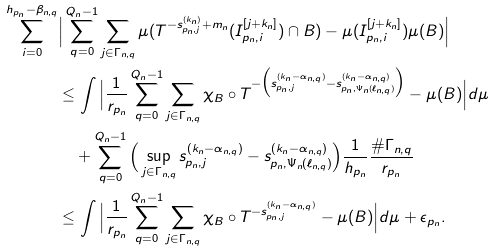Convert formula to latex. <formula><loc_0><loc_0><loc_500><loc_500>\sum _ { i = 0 } ^ { h _ { p _ { n } } - \beta _ { n , q } } & \Big { | } \sum _ { q = 0 } ^ { Q _ { n } - 1 } \sum _ { j \in \Gamma _ { n , q } } \mu ( T ^ { - s _ { p _ { n } , j } ^ { ( k _ { n } ) } + m _ { n } } ( I _ { p _ { n } , i } ^ { [ j + k _ { n } ] } ) \cap B ) - \mu ( I _ { p _ { n } , i } ^ { [ j + k _ { n } ] } ) \mu ( B ) \Big { | } \\ & \leq \int \Big { | } \frac { 1 } { r _ { p _ { n } } } \sum _ { q = 0 } ^ { Q _ { n } - 1 } \sum _ { j \in \Gamma _ { n , q } } \chi _ { B } \circ T ^ { - \Big { ( } s _ { p _ { n } , j } ^ { ( k _ { n } - \alpha _ { n , q } ) } - s _ { p _ { n } , \Psi _ { n } ( \ell _ { n , q } ) } ^ { ( k _ { n } - \alpha _ { n , q } ) } \Big { ) } } - \mu ( B ) \Big { | } d \mu \\ & \quad + \sum _ { q = 0 } ^ { Q _ { n } - 1 } \Big { ( } \sup _ { j \in \Gamma _ { n , q } } s _ { p _ { n } , j } ^ { ( k _ { n } - \alpha _ { n , q } ) } - s _ { p _ { n } , \Psi _ { n } ( \ell _ { n , q } ) } ^ { ( k _ { n } - \alpha _ { n , q } ) } \Big { ) } \frac { 1 } { h _ { p _ { n } } } \frac { \# \Gamma _ { n , q } } { r _ { p _ { n } } } \\ & \leq \int \Big { | } \frac { 1 } { r _ { p _ { n } } } \sum _ { q = 0 } ^ { Q _ { n } - 1 } \sum _ { j \in \Gamma _ { n , q } } \chi _ { B } \circ T ^ { - s _ { p _ { n } , j } ^ { ( k _ { n } - \alpha _ { n , q } ) } } - \mu ( B ) \Big { | } d \mu + \epsilon _ { p _ { n } } .</formula> 